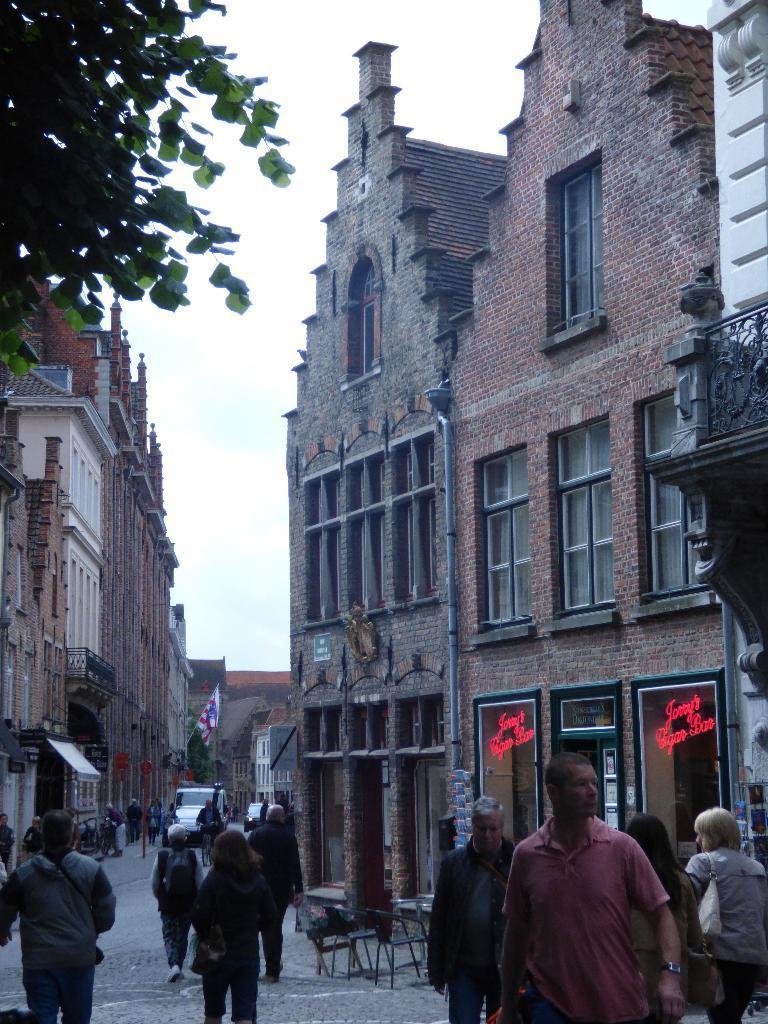Can you describe this image briefly? In the image we can see there are buildings and these are the windows of the buildings. There are even people around, they are walking and they are wearing clothes. Here we can see chairs and a tree. Here we can see the flag and there are even vehicles. Here we can see footpath, road, leaves and the sky. 